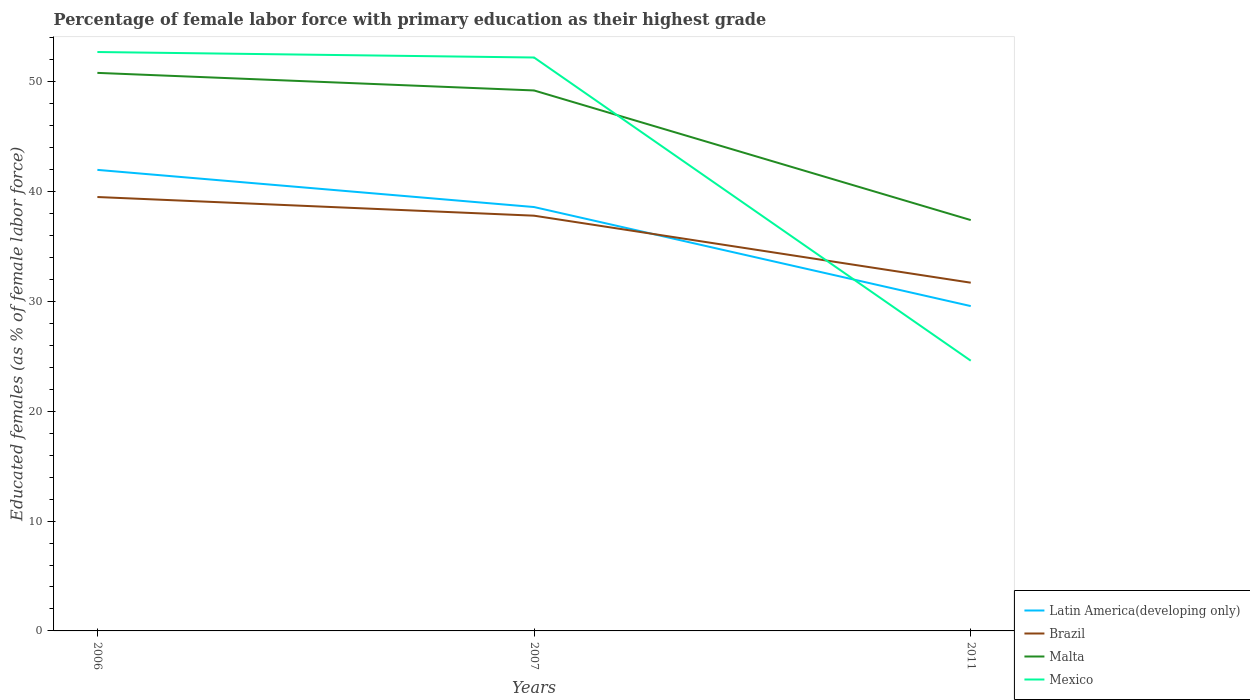Does the line corresponding to Brazil intersect with the line corresponding to Mexico?
Your answer should be very brief. Yes. Is the number of lines equal to the number of legend labels?
Provide a short and direct response. Yes. Across all years, what is the maximum percentage of female labor force with primary education in Latin America(developing only)?
Your answer should be very brief. 29.57. In which year was the percentage of female labor force with primary education in Brazil maximum?
Your response must be concise. 2011. What is the total percentage of female labor force with primary education in Latin America(developing only) in the graph?
Provide a short and direct response. 9.02. What is the difference between the highest and the second highest percentage of female labor force with primary education in Latin America(developing only)?
Provide a short and direct response. 12.4. What is the difference between the highest and the lowest percentage of female labor force with primary education in Brazil?
Keep it short and to the point. 2. What is the difference between two consecutive major ticks on the Y-axis?
Keep it short and to the point. 10. Does the graph contain grids?
Provide a succinct answer. No. How many legend labels are there?
Ensure brevity in your answer.  4. What is the title of the graph?
Your answer should be very brief. Percentage of female labor force with primary education as their highest grade. Does "West Bank and Gaza" appear as one of the legend labels in the graph?
Offer a very short reply. No. What is the label or title of the X-axis?
Make the answer very short. Years. What is the label or title of the Y-axis?
Your answer should be very brief. Educated females (as % of female labor force). What is the Educated females (as % of female labor force) in Latin America(developing only) in 2006?
Give a very brief answer. 41.97. What is the Educated females (as % of female labor force) of Brazil in 2006?
Provide a short and direct response. 39.5. What is the Educated females (as % of female labor force) in Malta in 2006?
Offer a very short reply. 50.8. What is the Educated females (as % of female labor force) in Mexico in 2006?
Ensure brevity in your answer.  52.7. What is the Educated females (as % of female labor force) in Latin America(developing only) in 2007?
Provide a succinct answer. 38.59. What is the Educated females (as % of female labor force) of Brazil in 2007?
Give a very brief answer. 37.8. What is the Educated females (as % of female labor force) of Malta in 2007?
Provide a succinct answer. 49.2. What is the Educated females (as % of female labor force) of Mexico in 2007?
Ensure brevity in your answer.  52.2. What is the Educated females (as % of female labor force) in Latin America(developing only) in 2011?
Provide a short and direct response. 29.57. What is the Educated females (as % of female labor force) of Brazil in 2011?
Ensure brevity in your answer.  31.7. What is the Educated females (as % of female labor force) of Malta in 2011?
Offer a very short reply. 37.4. What is the Educated females (as % of female labor force) of Mexico in 2011?
Give a very brief answer. 24.6. Across all years, what is the maximum Educated females (as % of female labor force) in Latin America(developing only)?
Provide a short and direct response. 41.97. Across all years, what is the maximum Educated females (as % of female labor force) of Brazil?
Provide a short and direct response. 39.5. Across all years, what is the maximum Educated females (as % of female labor force) of Malta?
Provide a short and direct response. 50.8. Across all years, what is the maximum Educated females (as % of female labor force) of Mexico?
Offer a very short reply. 52.7. Across all years, what is the minimum Educated females (as % of female labor force) of Latin America(developing only)?
Your response must be concise. 29.57. Across all years, what is the minimum Educated females (as % of female labor force) of Brazil?
Offer a terse response. 31.7. Across all years, what is the minimum Educated females (as % of female labor force) of Malta?
Offer a terse response. 37.4. Across all years, what is the minimum Educated females (as % of female labor force) of Mexico?
Your response must be concise. 24.6. What is the total Educated females (as % of female labor force) of Latin America(developing only) in the graph?
Offer a terse response. 110.13. What is the total Educated females (as % of female labor force) in Brazil in the graph?
Make the answer very short. 109. What is the total Educated females (as % of female labor force) in Malta in the graph?
Your answer should be very brief. 137.4. What is the total Educated females (as % of female labor force) in Mexico in the graph?
Provide a short and direct response. 129.5. What is the difference between the Educated females (as % of female labor force) of Latin America(developing only) in 2006 and that in 2007?
Offer a very short reply. 3.38. What is the difference between the Educated females (as % of female labor force) of Brazil in 2006 and that in 2007?
Offer a terse response. 1.7. What is the difference between the Educated females (as % of female labor force) in Malta in 2006 and that in 2007?
Offer a terse response. 1.6. What is the difference between the Educated females (as % of female labor force) of Latin America(developing only) in 2006 and that in 2011?
Give a very brief answer. 12.4. What is the difference between the Educated females (as % of female labor force) in Mexico in 2006 and that in 2011?
Give a very brief answer. 28.1. What is the difference between the Educated females (as % of female labor force) of Latin America(developing only) in 2007 and that in 2011?
Your response must be concise. 9.02. What is the difference between the Educated females (as % of female labor force) in Mexico in 2007 and that in 2011?
Make the answer very short. 27.6. What is the difference between the Educated females (as % of female labor force) of Latin America(developing only) in 2006 and the Educated females (as % of female labor force) of Brazil in 2007?
Your answer should be very brief. 4.17. What is the difference between the Educated females (as % of female labor force) in Latin America(developing only) in 2006 and the Educated females (as % of female labor force) in Malta in 2007?
Your response must be concise. -7.23. What is the difference between the Educated females (as % of female labor force) in Latin America(developing only) in 2006 and the Educated females (as % of female labor force) in Mexico in 2007?
Give a very brief answer. -10.23. What is the difference between the Educated females (as % of female labor force) in Brazil in 2006 and the Educated females (as % of female labor force) in Malta in 2007?
Keep it short and to the point. -9.7. What is the difference between the Educated females (as % of female labor force) in Brazil in 2006 and the Educated females (as % of female labor force) in Mexico in 2007?
Provide a succinct answer. -12.7. What is the difference between the Educated females (as % of female labor force) in Latin America(developing only) in 2006 and the Educated females (as % of female labor force) in Brazil in 2011?
Make the answer very short. 10.27. What is the difference between the Educated females (as % of female labor force) of Latin America(developing only) in 2006 and the Educated females (as % of female labor force) of Malta in 2011?
Offer a very short reply. 4.57. What is the difference between the Educated females (as % of female labor force) in Latin America(developing only) in 2006 and the Educated females (as % of female labor force) in Mexico in 2011?
Ensure brevity in your answer.  17.37. What is the difference between the Educated females (as % of female labor force) in Brazil in 2006 and the Educated females (as % of female labor force) in Malta in 2011?
Your response must be concise. 2.1. What is the difference between the Educated females (as % of female labor force) in Brazil in 2006 and the Educated females (as % of female labor force) in Mexico in 2011?
Give a very brief answer. 14.9. What is the difference between the Educated females (as % of female labor force) in Malta in 2006 and the Educated females (as % of female labor force) in Mexico in 2011?
Offer a very short reply. 26.2. What is the difference between the Educated females (as % of female labor force) in Latin America(developing only) in 2007 and the Educated females (as % of female labor force) in Brazil in 2011?
Keep it short and to the point. 6.89. What is the difference between the Educated females (as % of female labor force) of Latin America(developing only) in 2007 and the Educated females (as % of female labor force) of Malta in 2011?
Offer a terse response. 1.19. What is the difference between the Educated females (as % of female labor force) in Latin America(developing only) in 2007 and the Educated females (as % of female labor force) in Mexico in 2011?
Your answer should be compact. 13.99. What is the difference between the Educated females (as % of female labor force) in Brazil in 2007 and the Educated females (as % of female labor force) in Malta in 2011?
Offer a very short reply. 0.4. What is the difference between the Educated females (as % of female labor force) in Malta in 2007 and the Educated females (as % of female labor force) in Mexico in 2011?
Your answer should be compact. 24.6. What is the average Educated females (as % of female labor force) of Latin America(developing only) per year?
Make the answer very short. 36.71. What is the average Educated females (as % of female labor force) in Brazil per year?
Offer a very short reply. 36.33. What is the average Educated females (as % of female labor force) in Malta per year?
Provide a succinct answer. 45.8. What is the average Educated females (as % of female labor force) in Mexico per year?
Provide a short and direct response. 43.17. In the year 2006, what is the difference between the Educated females (as % of female labor force) in Latin America(developing only) and Educated females (as % of female labor force) in Brazil?
Your answer should be compact. 2.47. In the year 2006, what is the difference between the Educated females (as % of female labor force) in Latin America(developing only) and Educated females (as % of female labor force) in Malta?
Your response must be concise. -8.83. In the year 2006, what is the difference between the Educated females (as % of female labor force) in Latin America(developing only) and Educated females (as % of female labor force) in Mexico?
Your answer should be very brief. -10.73. In the year 2006, what is the difference between the Educated females (as % of female labor force) in Brazil and Educated females (as % of female labor force) in Malta?
Provide a succinct answer. -11.3. In the year 2006, what is the difference between the Educated females (as % of female labor force) in Brazil and Educated females (as % of female labor force) in Mexico?
Your answer should be compact. -13.2. In the year 2006, what is the difference between the Educated females (as % of female labor force) in Malta and Educated females (as % of female labor force) in Mexico?
Make the answer very short. -1.9. In the year 2007, what is the difference between the Educated females (as % of female labor force) in Latin America(developing only) and Educated females (as % of female labor force) in Brazil?
Provide a short and direct response. 0.79. In the year 2007, what is the difference between the Educated females (as % of female labor force) of Latin America(developing only) and Educated females (as % of female labor force) of Malta?
Offer a very short reply. -10.61. In the year 2007, what is the difference between the Educated females (as % of female labor force) of Latin America(developing only) and Educated females (as % of female labor force) of Mexico?
Offer a terse response. -13.61. In the year 2007, what is the difference between the Educated females (as % of female labor force) in Brazil and Educated females (as % of female labor force) in Malta?
Make the answer very short. -11.4. In the year 2007, what is the difference between the Educated females (as % of female labor force) in Brazil and Educated females (as % of female labor force) in Mexico?
Your answer should be compact. -14.4. In the year 2011, what is the difference between the Educated females (as % of female labor force) in Latin America(developing only) and Educated females (as % of female labor force) in Brazil?
Give a very brief answer. -2.13. In the year 2011, what is the difference between the Educated females (as % of female labor force) in Latin America(developing only) and Educated females (as % of female labor force) in Malta?
Keep it short and to the point. -7.83. In the year 2011, what is the difference between the Educated females (as % of female labor force) of Latin America(developing only) and Educated females (as % of female labor force) of Mexico?
Your answer should be compact. 4.97. What is the ratio of the Educated females (as % of female labor force) in Latin America(developing only) in 2006 to that in 2007?
Give a very brief answer. 1.09. What is the ratio of the Educated females (as % of female labor force) in Brazil in 2006 to that in 2007?
Ensure brevity in your answer.  1.04. What is the ratio of the Educated females (as % of female labor force) in Malta in 2006 to that in 2007?
Give a very brief answer. 1.03. What is the ratio of the Educated females (as % of female labor force) in Mexico in 2006 to that in 2007?
Your answer should be compact. 1.01. What is the ratio of the Educated females (as % of female labor force) of Latin America(developing only) in 2006 to that in 2011?
Provide a short and direct response. 1.42. What is the ratio of the Educated females (as % of female labor force) of Brazil in 2006 to that in 2011?
Keep it short and to the point. 1.25. What is the ratio of the Educated females (as % of female labor force) of Malta in 2006 to that in 2011?
Your answer should be very brief. 1.36. What is the ratio of the Educated females (as % of female labor force) of Mexico in 2006 to that in 2011?
Make the answer very short. 2.14. What is the ratio of the Educated females (as % of female labor force) in Latin America(developing only) in 2007 to that in 2011?
Provide a succinct answer. 1.3. What is the ratio of the Educated females (as % of female labor force) in Brazil in 2007 to that in 2011?
Your answer should be very brief. 1.19. What is the ratio of the Educated females (as % of female labor force) of Malta in 2007 to that in 2011?
Make the answer very short. 1.32. What is the ratio of the Educated females (as % of female labor force) in Mexico in 2007 to that in 2011?
Your answer should be very brief. 2.12. What is the difference between the highest and the second highest Educated females (as % of female labor force) of Latin America(developing only)?
Offer a terse response. 3.38. What is the difference between the highest and the second highest Educated females (as % of female labor force) in Brazil?
Your answer should be compact. 1.7. What is the difference between the highest and the second highest Educated females (as % of female labor force) in Malta?
Your answer should be very brief. 1.6. What is the difference between the highest and the lowest Educated females (as % of female labor force) in Latin America(developing only)?
Your answer should be very brief. 12.4. What is the difference between the highest and the lowest Educated females (as % of female labor force) of Malta?
Keep it short and to the point. 13.4. What is the difference between the highest and the lowest Educated females (as % of female labor force) in Mexico?
Provide a short and direct response. 28.1. 